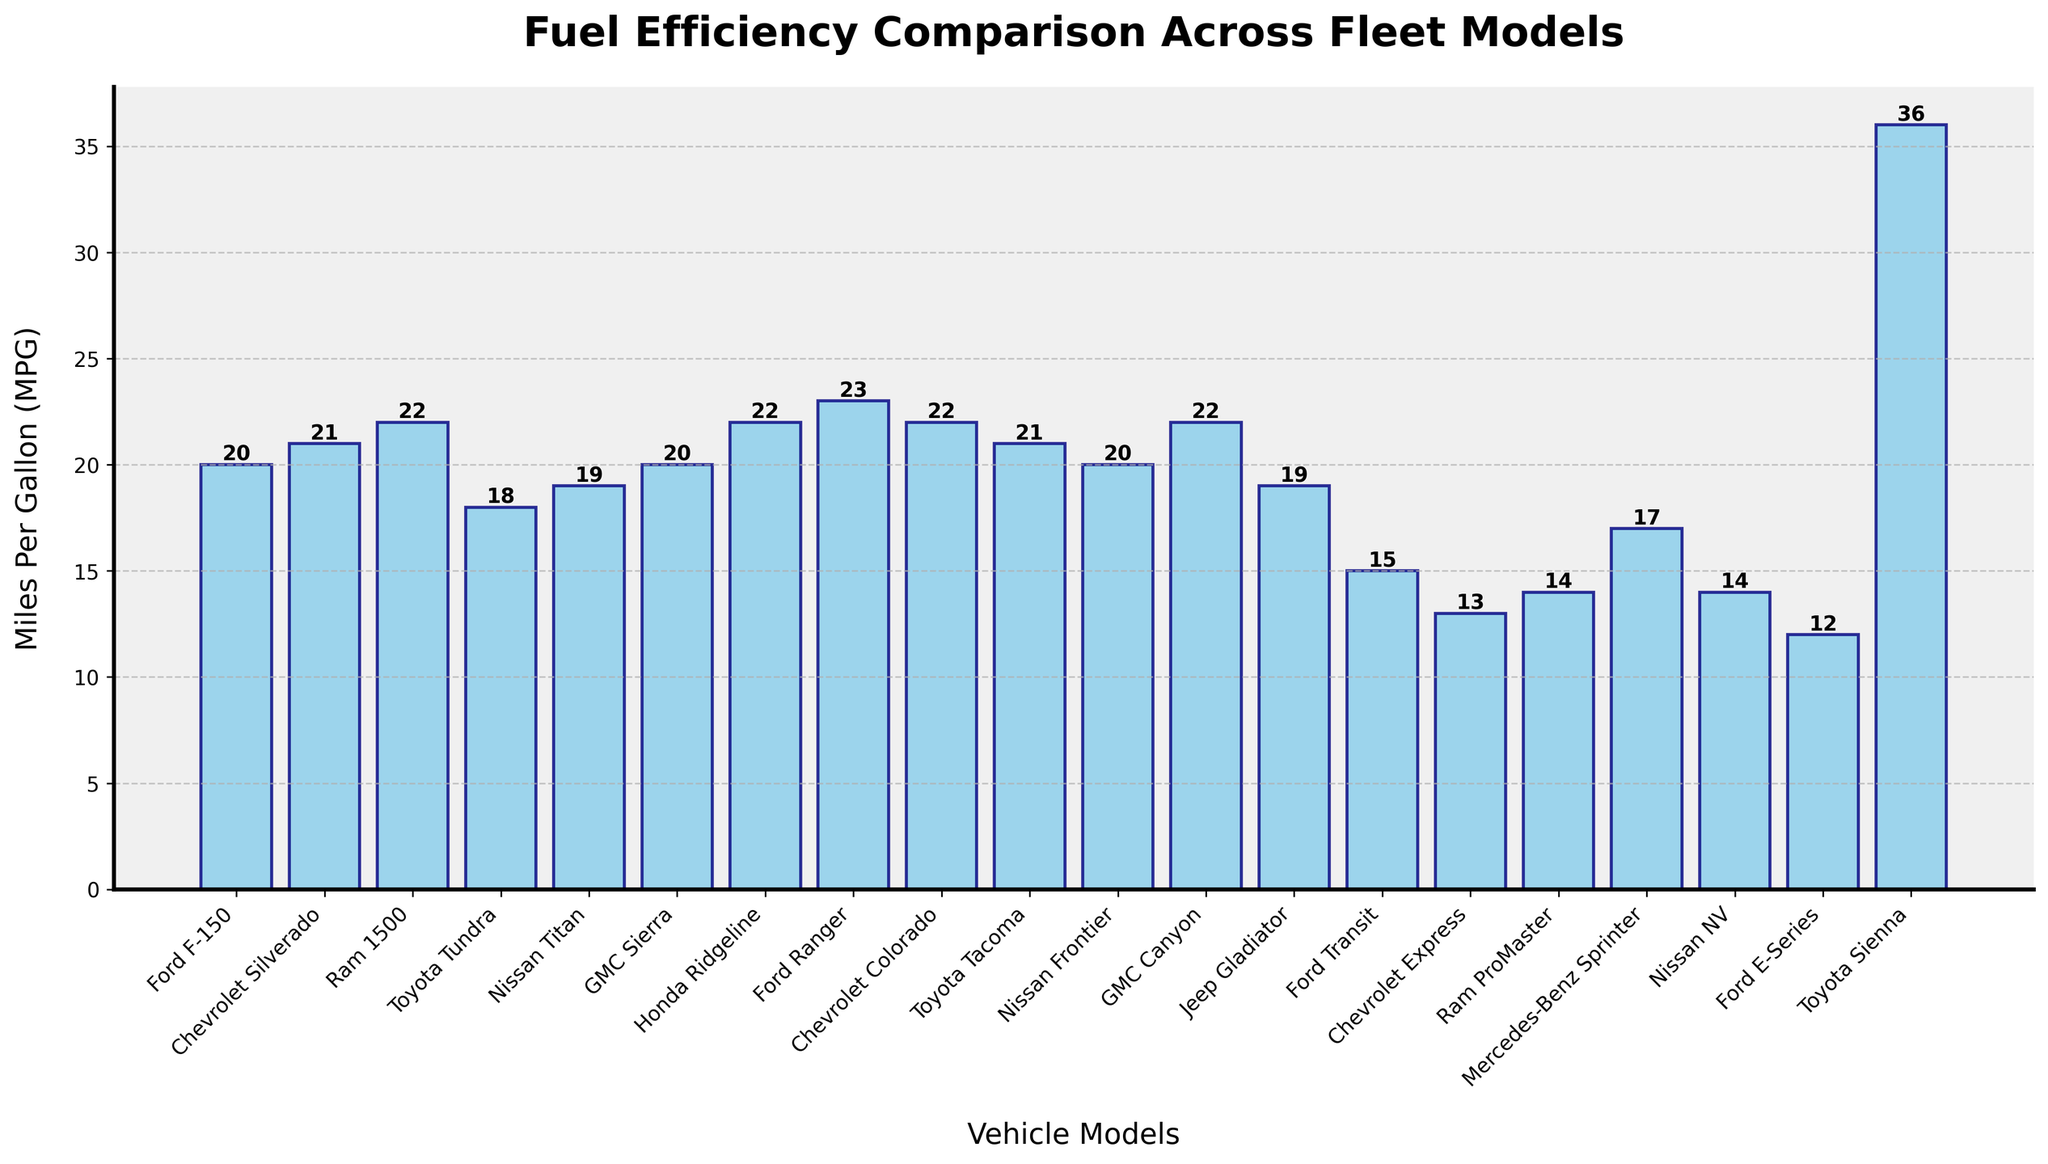Which vehicle model has the highest fuel efficiency? According to the height of the bars, the Toyota Sienna has the highest bar, indicating the highest MPG at 36.
Answer: Toyota Sienna Which vehicle model has the lowest fuel efficiency? The Ford E-Series has the shortest bar, indicating the lowest MPG at 12.
Answer: Ford E-Series How much greater is the fuel efficiency of the Toyota Sienna compared to the Ford Transit? The Toyota Sienna's MPG is 36, and the Ford Transit's MPG is 15. By subtracting 15 from 36, we find the difference is 21.
Answer: 21 Which models have an MPG greater than 20 but less than 23? The vehicles with bars that reach a height between 20 and 23 MPGs are the Chevrolet Silverado (21), Ram 1500 (22), Honda Ridgeline (22), Chevrolet Colorado (22), Toyota Tacoma (21), GMC Canyon (22), and Ford Ranger (23).
Answer: Chevrolet Silverado, Ram 1500, Honda Ridgeline, Chevrolet Colorado, Toyota Tacoma, GMC Canyon, Ford Ranger What is the average MPG of the Chevrolet Colorado, Toyota Tacoma, and GMC Canyon? The MPGs for the Chevrolet Colorado, Toyota Tacoma, and GMC Canyon are 22, 21, and 22 respectively. Adding these together gives 65. Dividing by the 3 models, the average is 65 / 3 = 21.67.
Answer: 21.67 How much more fuel-efficient is the Ram 1500 compared to the Jeep Gladiator? The MPG of the Ram 1500 is 22, and the Jeep Gladiator is 19. Subtracting 19 from 22 gives a difference of 3.
Answer: 3 If we group all vehicle models into two categories: those with MPGs above 20 and those with MPGs 20 or below, what is the count of models in each group? There are 10 models with MPGs above 20 (Ram 1500, Honda Ridgeline, Ford Ranger, Chevrolet Colorado, GMC Canyon, Toyota Sienna) and 9 models with MPGs 20 or below (Ford F-150, Chevrolet Silverado, Toyota Tundra, Nissan Titan, GMC Sierra, Nissan Frontier, Jeep Gladiator, Ford Transit, Chevrolet Express, Ram ProMaster, Mercedes-Benz Sprinter, Nissan NV, Ford E-Series).
Answer: Above 20: 10, 20 or below: 9 What is the difference in fuel efficiency between the most efficient truck (Ford Ranger) and the most efficient van (Toyota Sienna)? The MPG of the Ford Ranger is 23, and the MPG of the Toyota Sienna is 36. The difference is 36 - 23 = 13.
Answer: 13 Which models have fuel efficiencies exactly equal to the average MPG of the entire fleet? To find the average MPG, sum all the MPGs and divide by the number of models. The total sum is 378, and there are 19 vehicle models. The average is 378 / 19 = 19.89, approximately 20. Models with MPG of 20 include the Ford F-150, GMC Sierra, and Nissan Frontier.
Answer: Ford F-150, GMC Sierra, Nissan Frontier What is the combined MPG of all models from Toyota? The MPGs for the Toyota trucks are Tundra (18), Tacoma (21), and Sienna (36). Adding these together, 18 + 21 + 36 = 75.
Answer: 75 Which vehicle models have an MPG less than 15? The vehicle models with MPGs less than 15 are the Chevrolet Express (13), Ram ProMaster (14), Nissan NV (14), and Ford E-Series (12).
Answer: Chevrolet Express, Ram ProMaster, Nissan NV, Ford E-Series 